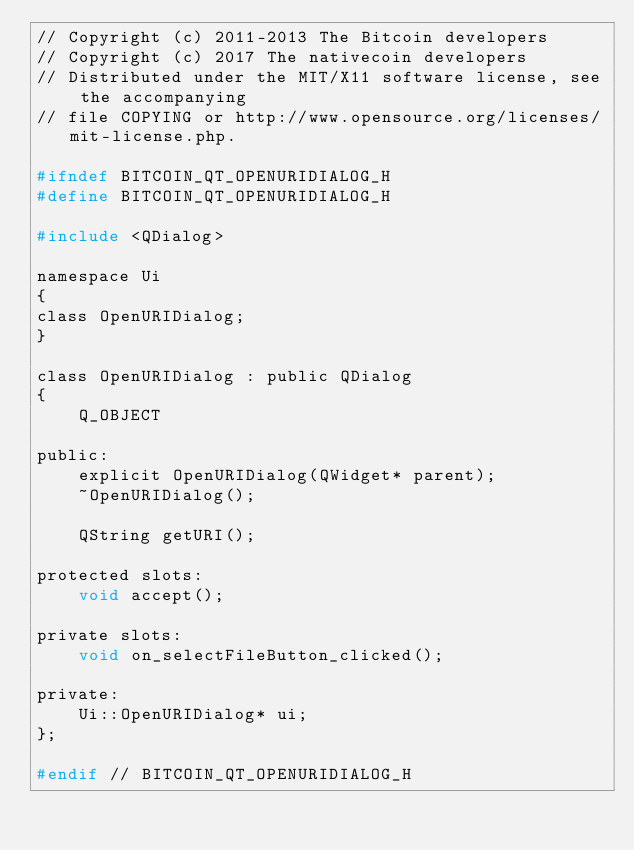<code> <loc_0><loc_0><loc_500><loc_500><_C_>// Copyright (c) 2011-2013 The Bitcoin developers
// Copyright (c) 2017 The nativecoin developers
// Distributed under the MIT/X11 software license, see the accompanying
// file COPYING or http://www.opensource.org/licenses/mit-license.php.

#ifndef BITCOIN_QT_OPENURIDIALOG_H
#define BITCOIN_QT_OPENURIDIALOG_H

#include <QDialog>

namespace Ui
{
class OpenURIDialog;
}

class OpenURIDialog : public QDialog
{
    Q_OBJECT

public:
    explicit OpenURIDialog(QWidget* parent);
    ~OpenURIDialog();

    QString getURI();

protected slots:
    void accept();

private slots:
    void on_selectFileButton_clicked();

private:
    Ui::OpenURIDialog* ui;
};

#endif // BITCOIN_QT_OPENURIDIALOG_H
</code> 